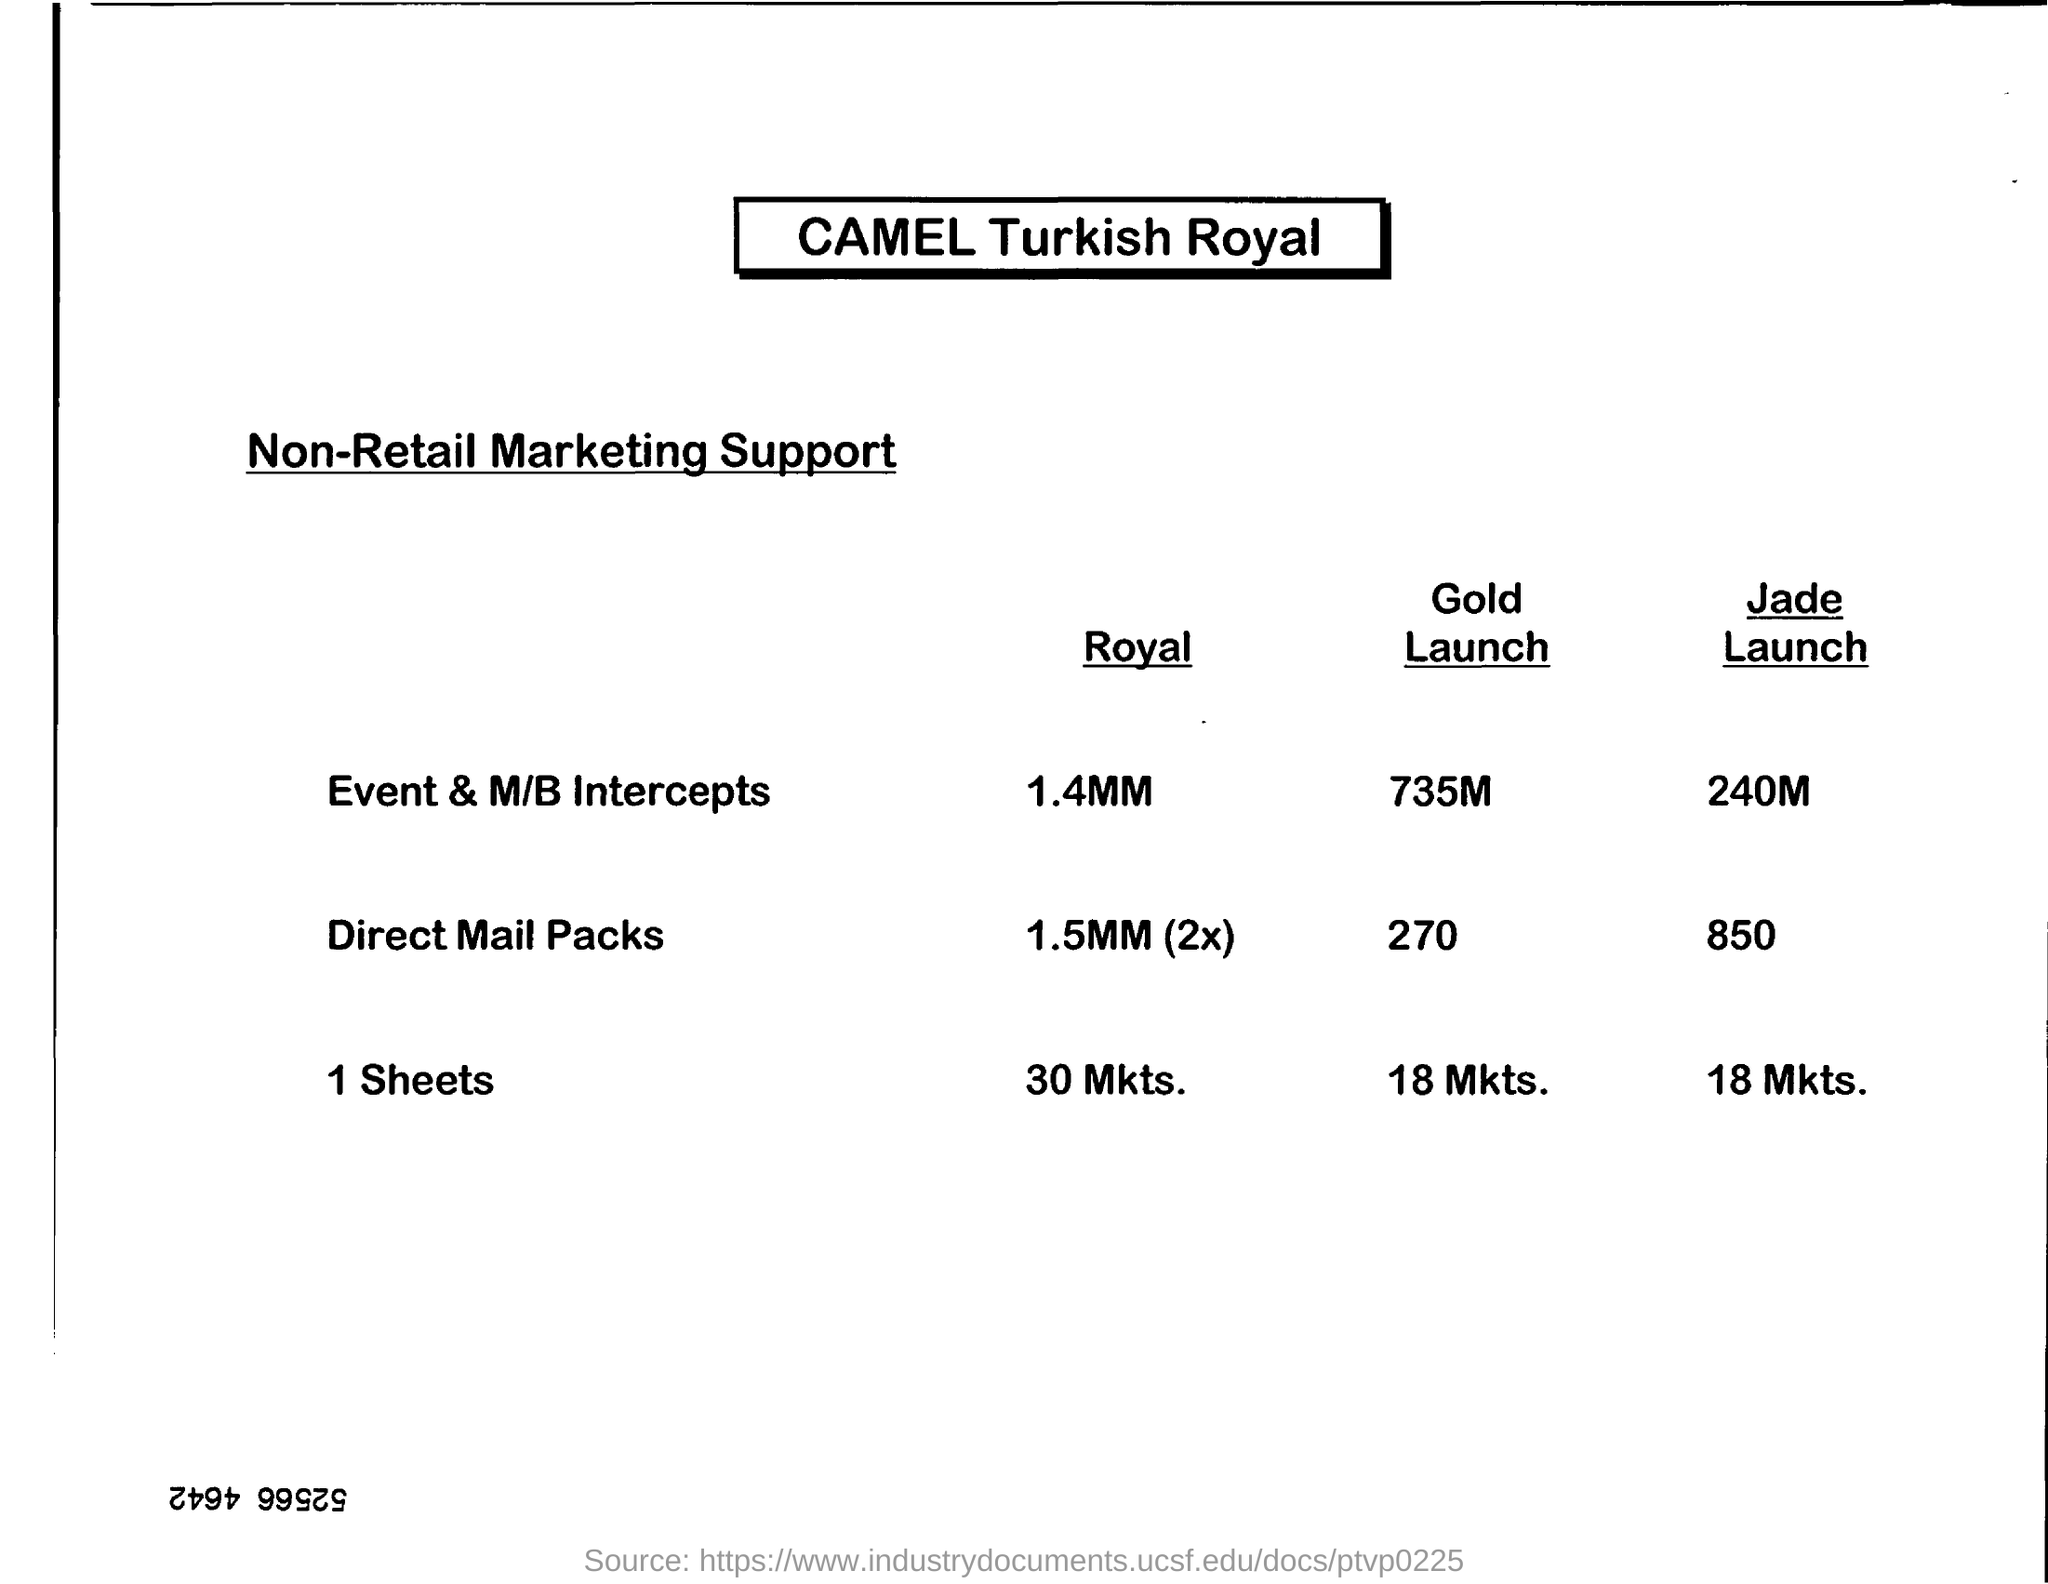Indicate a few pertinent items in this graphic. The Direct Mail Packs for Gold Launch is a declaration that consists of 270 characters. What is the Direct Mail Packs for Jade Launch? It is an 850.. 